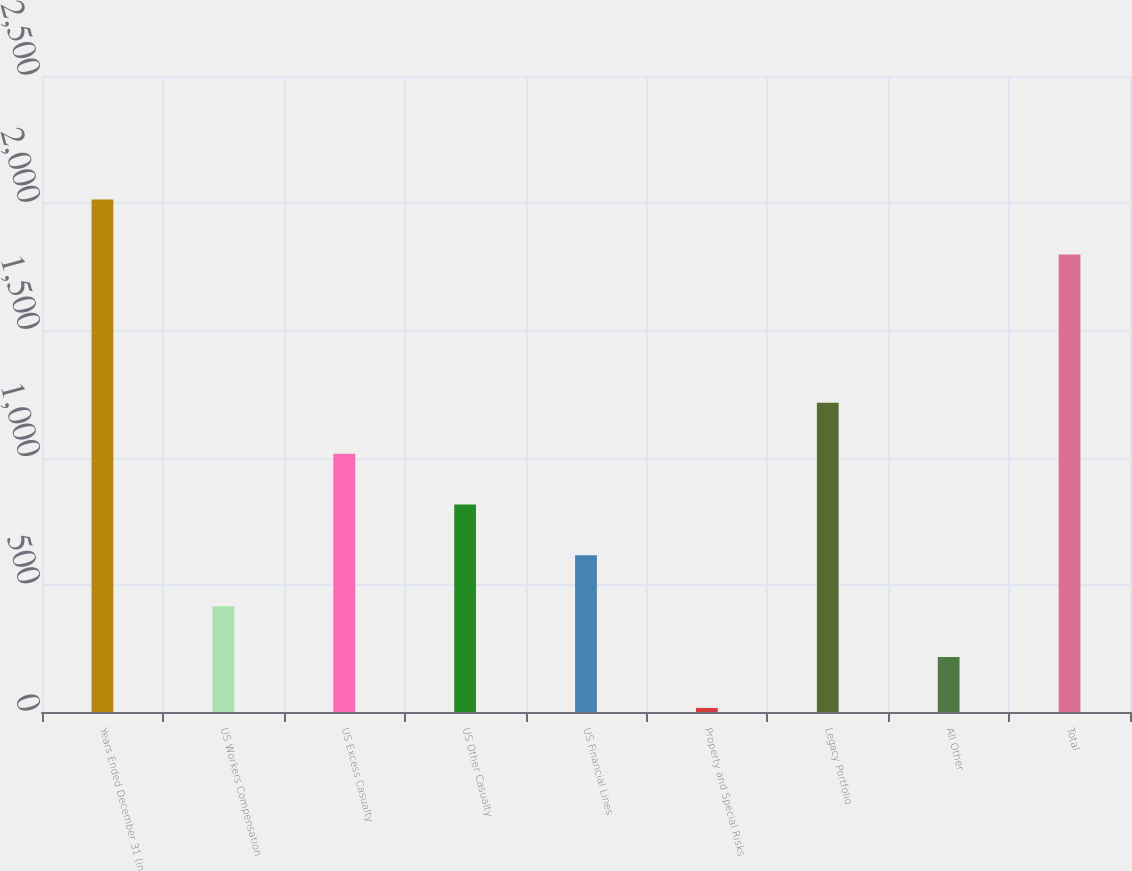Convert chart to OTSL. <chart><loc_0><loc_0><loc_500><loc_500><bar_chart><fcel>Years Ended December 31 (in<fcel>US Workers Compensation<fcel>US Excess Casualty<fcel>US Other Casualty<fcel>US Financial Lines<fcel>Property and Special Risks<fcel>Legacy Portfolio<fcel>All Other<fcel>Total<nl><fcel>2015<fcel>415.8<fcel>1015.5<fcel>815.6<fcel>615.7<fcel>16<fcel>1215.4<fcel>215.9<fcel>1798<nl></chart> 